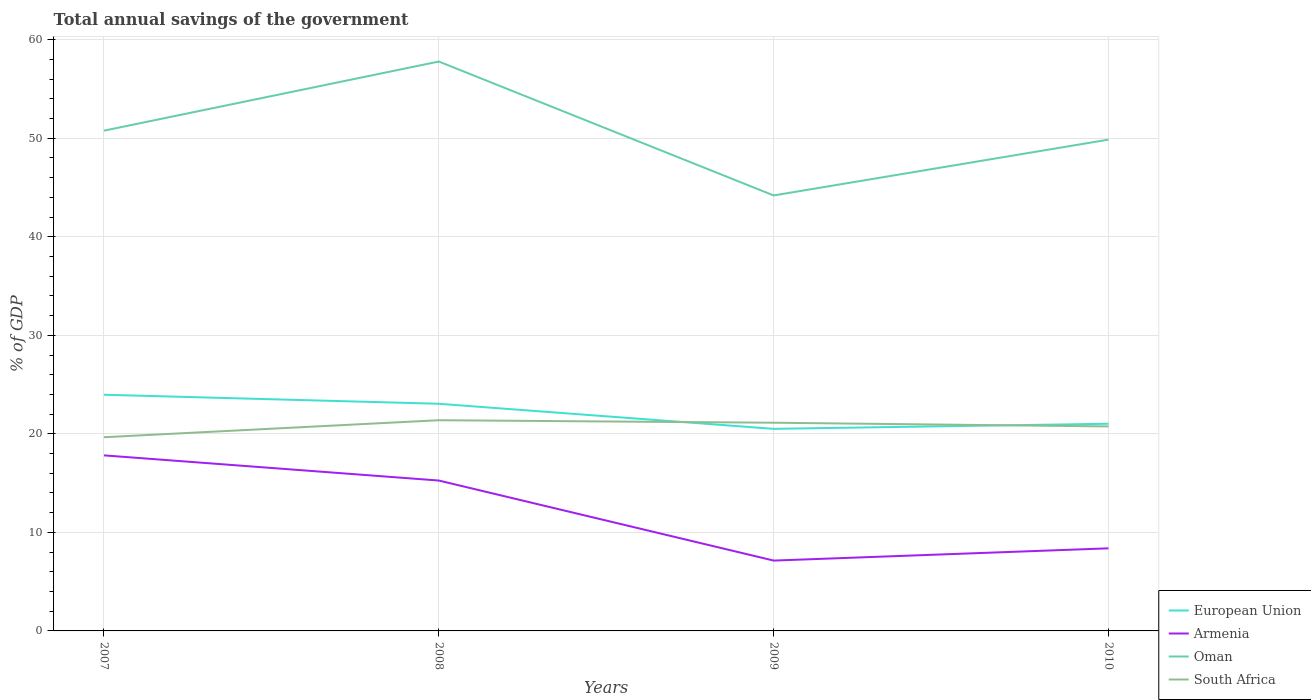Across all years, what is the maximum total annual savings of the government in Oman?
Provide a short and direct response. 44.2. What is the total total annual savings of the government in European Union in the graph?
Offer a terse response. -0.52. What is the difference between the highest and the second highest total annual savings of the government in Armenia?
Your answer should be compact. 10.68. How many lines are there?
Give a very brief answer. 4. How many years are there in the graph?
Provide a short and direct response. 4. Does the graph contain any zero values?
Your answer should be compact. No. Does the graph contain grids?
Provide a succinct answer. Yes. Where does the legend appear in the graph?
Ensure brevity in your answer.  Bottom right. How many legend labels are there?
Keep it short and to the point. 4. How are the legend labels stacked?
Your answer should be compact. Vertical. What is the title of the graph?
Provide a succinct answer. Total annual savings of the government. What is the label or title of the Y-axis?
Give a very brief answer. % of GDP. What is the % of GDP in European Union in 2007?
Keep it short and to the point. 23.97. What is the % of GDP in Armenia in 2007?
Ensure brevity in your answer.  17.82. What is the % of GDP of Oman in 2007?
Provide a succinct answer. 50.77. What is the % of GDP of South Africa in 2007?
Offer a terse response. 19.66. What is the % of GDP in European Union in 2008?
Provide a short and direct response. 23.05. What is the % of GDP of Armenia in 2008?
Your answer should be very brief. 15.26. What is the % of GDP of Oman in 2008?
Provide a short and direct response. 57.79. What is the % of GDP in South Africa in 2008?
Ensure brevity in your answer.  21.38. What is the % of GDP in European Union in 2009?
Make the answer very short. 20.51. What is the % of GDP of Armenia in 2009?
Ensure brevity in your answer.  7.14. What is the % of GDP of Oman in 2009?
Offer a very short reply. 44.2. What is the % of GDP in South Africa in 2009?
Your answer should be very brief. 21.13. What is the % of GDP of European Union in 2010?
Your answer should be compact. 21.03. What is the % of GDP in Armenia in 2010?
Make the answer very short. 8.38. What is the % of GDP in Oman in 2010?
Give a very brief answer. 49.86. What is the % of GDP of South Africa in 2010?
Ensure brevity in your answer.  20.75. Across all years, what is the maximum % of GDP in European Union?
Make the answer very short. 23.97. Across all years, what is the maximum % of GDP in Armenia?
Offer a terse response. 17.82. Across all years, what is the maximum % of GDP of Oman?
Offer a terse response. 57.79. Across all years, what is the maximum % of GDP in South Africa?
Give a very brief answer. 21.38. Across all years, what is the minimum % of GDP in European Union?
Offer a very short reply. 20.51. Across all years, what is the minimum % of GDP of Armenia?
Provide a short and direct response. 7.14. Across all years, what is the minimum % of GDP in Oman?
Your response must be concise. 44.2. Across all years, what is the minimum % of GDP in South Africa?
Your response must be concise. 19.66. What is the total % of GDP of European Union in the graph?
Provide a succinct answer. 88.56. What is the total % of GDP of Armenia in the graph?
Your response must be concise. 48.6. What is the total % of GDP in Oman in the graph?
Your answer should be compact. 202.62. What is the total % of GDP of South Africa in the graph?
Ensure brevity in your answer.  82.93. What is the difference between the % of GDP of European Union in 2007 and that in 2008?
Your answer should be compact. 0.92. What is the difference between the % of GDP in Armenia in 2007 and that in 2008?
Your answer should be very brief. 2.55. What is the difference between the % of GDP in Oman in 2007 and that in 2008?
Make the answer very short. -7.02. What is the difference between the % of GDP in South Africa in 2007 and that in 2008?
Offer a terse response. -1.73. What is the difference between the % of GDP of European Union in 2007 and that in 2009?
Offer a terse response. 3.46. What is the difference between the % of GDP in Armenia in 2007 and that in 2009?
Make the answer very short. 10.68. What is the difference between the % of GDP of Oman in 2007 and that in 2009?
Provide a succinct answer. 6.57. What is the difference between the % of GDP in South Africa in 2007 and that in 2009?
Your response must be concise. -1.47. What is the difference between the % of GDP of European Union in 2007 and that in 2010?
Your answer should be compact. 2.95. What is the difference between the % of GDP of Armenia in 2007 and that in 2010?
Offer a very short reply. 9.44. What is the difference between the % of GDP of Oman in 2007 and that in 2010?
Make the answer very short. 0.91. What is the difference between the % of GDP of South Africa in 2007 and that in 2010?
Keep it short and to the point. -1.1. What is the difference between the % of GDP of European Union in 2008 and that in 2009?
Give a very brief answer. 2.54. What is the difference between the % of GDP of Armenia in 2008 and that in 2009?
Ensure brevity in your answer.  8.12. What is the difference between the % of GDP of Oman in 2008 and that in 2009?
Provide a short and direct response. 13.59. What is the difference between the % of GDP of South Africa in 2008 and that in 2009?
Provide a succinct answer. 0.25. What is the difference between the % of GDP of European Union in 2008 and that in 2010?
Provide a short and direct response. 2.03. What is the difference between the % of GDP of Armenia in 2008 and that in 2010?
Make the answer very short. 6.88. What is the difference between the % of GDP of Oman in 2008 and that in 2010?
Keep it short and to the point. 7.92. What is the difference between the % of GDP of South Africa in 2008 and that in 2010?
Make the answer very short. 0.63. What is the difference between the % of GDP of European Union in 2009 and that in 2010?
Make the answer very short. -0.52. What is the difference between the % of GDP in Armenia in 2009 and that in 2010?
Ensure brevity in your answer.  -1.24. What is the difference between the % of GDP in Oman in 2009 and that in 2010?
Your answer should be very brief. -5.67. What is the difference between the % of GDP of South Africa in 2009 and that in 2010?
Make the answer very short. 0.38. What is the difference between the % of GDP of European Union in 2007 and the % of GDP of Armenia in 2008?
Your answer should be very brief. 8.71. What is the difference between the % of GDP of European Union in 2007 and the % of GDP of Oman in 2008?
Your response must be concise. -33.82. What is the difference between the % of GDP of European Union in 2007 and the % of GDP of South Africa in 2008?
Offer a terse response. 2.59. What is the difference between the % of GDP of Armenia in 2007 and the % of GDP of Oman in 2008?
Your answer should be compact. -39.97. What is the difference between the % of GDP of Armenia in 2007 and the % of GDP of South Africa in 2008?
Your response must be concise. -3.57. What is the difference between the % of GDP in Oman in 2007 and the % of GDP in South Africa in 2008?
Your answer should be compact. 29.39. What is the difference between the % of GDP in European Union in 2007 and the % of GDP in Armenia in 2009?
Offer a very short reply. 16.83. What is the difference between the % of GDP in European Union in 2007 and the % of GDP in Oman in 2009?
Your answer should be compact. -20.23. What is the difference between the % of GDP in European Union in 2007 and the % of GDP in South Africa in 2009?
Offer a terse response. 2.84. What is the difference between the % of GDP in Armenia in 2007 and the % of GDP in Oman in 2009?
Offer a very short reply. -26.38. What is the difference between the % of GDP in Armenia in 2007 and the % of GDP in South Africa in 2009?
Your answer should be compact. -3.31. What is the difference between the % of GDP in Oman in 2007 and the % of GDP in South Africa in 2009?
Provide a succinct answer. 29.64. What is the difference between the % of GDP of European Union in 2007 and the % of GDP of Armenia in 2010?
Offer a very short reply. 15.59. What is the difference between the % of GDP in European Union in 2007 and the % of GDP in Oman in 2010?
Offer a very short reply. -25.89. What is the difference between the % of GDP in European Union in 2007 and the % of GDP in South Africa in 2010?
Offer a very short reply. 3.22. What is the difference between the % of GDP in Armenia in 2007 and the % of GDP in Oman in 2010?
Your answer should be very brief. -32.05. What is the difference between the % of GDP of Armenia in 2007 and the % of GDP of South Africa in 2010?
Give a very brief answer. -2.94. What is the difference between the % of GDP in Oman in 2007 and the % of GDP in South Africa in 2010?
Offer a very short reply. 30.02. What is the difference between the % of GDP of European Union in 2008 and the % of GDP of Armenia in 2009?
Keep it short and to the point. 15.91. What is the difference between the % of GDP in European Union in 2008 and the % of GDP in Oman in 2009?
Keep it short and to the point. -21.14. What is the difference between the % of GDP in European Union in 2008 and the % of GDP in South Africa in 2009?
Give a very brief answer. 1.92. What is the difference between the % of GDP of Armenia in 2008 and the % of GDP of Oman in 2009?
Give a very brief answer. -28.94. What is the difference between the % of GDP in Armenia in 2008 and the % of GDP in South Africa in 2009?
Provide a short and direct response. -5.87. What is the difference between the % of GDP of Oman in 2008 and the % of GDP of South Africa in 2009?
Provide a short and direct response. 36.66. What is the difference between the % of GDP of European Union in 2008 and the % of GDP of Armenia in 2010?
Your answer should be very brief. 14.67. What is the difference between the % of GDP in European Union in 2008 and the % of GDP in Oman in 2010?
Keep it short and to the point. -26.81. What is the difference between the % of GDP of European Union in 2008 and the % of GDP of South Africa in 2010?
Provide a short and direct response. 2.3. What is the difference between the % of GDP of Armenia in 2008 and the % of GDP of Oman in 2010?
Your response must be concise. -34.6. What is the difference between the % of GDP in Armenia in 2008 and the % of GDP in South Africa in 2010?
Your response must be concise. -5.49. What is the difference between the % of GDP in Oman in 2008 and the % of GDP in South Africa in 2010?
Offer a terse response. 37.03. What is the difference between the % of GDP of European Union in 2009 and the % of GDP of Armenia in 2010?
Offer a terse response. 12.13. What is the difference between the % of GDP of European Union in 2009 and the % of GDP of Oman in 2010?
Offer a terse response. -29.35. What is the difference between the % of GDP in European Union in 2009 and the % of GDP in South Africa in 2010?
Make the answer very short. -0.24. What is the difference between the % of GDP of Armenia in 2009 and the % of GDP of Oman in 2010?
Your answer should be very brief. -42.72. What is the difference between the % of GDP of Armenia in 2009 and the % of GDP of South Africa in 2010?
Make the answer very short. -13.61. What is the difference between the % of GDP in Oman in 2009 and the % of GDP in South Africa in 2010?
Provide a succinct answer. 23.44. What is the average % of GDP in European Union per year?
Keep it short and to the point. 22.14. What is the average % of GDP in Armenia per year?
Offer a terse response. 12.15. What is the average % of GDP in Oman per year?
Provide a succinct answer. 50.66. What is the average % of GDP of South Africa per year?
Offer a terse response. 20.73. In the year 2007, what is the difference between the % of GDP in European Union and % of GDP in Armenia?
Offer a very short reply. 6.15. In the year 2007, what is the difference between the % of GDP in European Union and % of GDP in Oman?
Give a very brief answer. -26.8. In the year 2007, what is the difference between the % of GDP in European Union and % of GDP in South Africa?
Provide a short and direct response. 4.31. In the year 2007, what is the difference between the % of GDP of Armenia and % of GDP of Oman?
Keep it short and to the point. -32.95. In the year 2007, what is the difference between the % of GDP in Armenia and % of GDP in South Africa?
Keep it short and to the point. -1.84. In the year 2007, what is the difference between the % of GDP in Oman and % of GDP in South Africa?
Your answer should be compact. 31.11. In the year 2008, what is the difference between the % of GDP of European Union and % of GDP of Armenia?
Your answer should be compact. 7.79. In the year 2008, what is the difference between the % of GDP of European Union and % of GDP of Oman?
Keep it short and to the point. -34.73. In the year 2008, what is the difference between the % of GDP of European Union and % of GDP of South Africa?
Make the answer very short. 1.67. In the year 2008, what is the difference between the % of GDP in Armenia and % of GDP in Oman?
Provide a short and direct response. -42.53. In the year 2008, what is the difference between the % of GDP in Armenia and % of GDP in South Africa?
Give a very brief answer. -6.12. In the year 2008, what is the difference between the % of GDP of Oman and % of GDP of South Africa?
Offer a very short reply. 36.4. In the year 2009, what is the difference between the % of GDP of European Union and % of GDP of Armenia?
Your answer should be compact. 13.37. In the year 2009, what is the difference between the % of GDP of European Union and % of GDP of Oman?
Your answer should be very brief. -23.69. In the year 2009, what is the difference between the % of GDP in European Union and % of GDP in South Africa?
Make the answer very short. -0.62. In the year 2009, what is the difference between the % of GDP in Armenia and % of GDP in Oman?
Keep it short and to the point. -37.06. In the year 2009, what is the difference between the % of GDP in Armenia and % of GDP in South Africa?
Keep it short and to the point. -13.99. In the year 2009, what is the difference between the % of GDP of Oman and % of GDP of South Africa?
Keep it short and to the point. 23.07. In the year 2010, what is the difference between the % of GDP in European Union and % of GDP in Armenia?
Provide a succinct answer. 12.64. In the year 2010, what is the difference between the % of GDP of European Union and % of GDP of Oman?
Give a very brief answer. -28.84. In the year 2010, what is the difference between the % of GDP in European Union and % of GDP in South Africa?
Make the answer very short. 0.27. In the year 2010, what is the difference between the % of GDP in Armenia and % of GDP in Oman?
Provide a short and direct response. -41.48. In the year 2010, what is the difference between the % of GDP in Armenia and % of GDP in South Africa?
Keep it short and to the point. -12.37. In the year 2010, what is the difference between the % of GDP in Oman and % of GDP in South Africa?
Provide a short and direct response. 29.11. What is the ratio of the % of GDP of European Union in 2007 to that in 2008?
Provide a succinct answer. 1.04. What is the ratio of the % of GDP in Armenia in 2007 to that in 2008?
Provide a succinct answer. 1.17. What is the ratio of the % of GDP of Oman in 2007 to that in 2008?
Offer a terse response. 0.88. What is the ratio of the % of GDP in South Africa in 2007 to that in 2008?
Your answer should be compact. 0.92. What is the ratio of the % of GDP of European Union in 2007 to that in 2009?
Make the answer very short. 1.17. What is the ratio of the % of GDP in Armenia in 2007 to that in 2009?
Keep it short and to the point. 2.5. What is the ratio of the % of GDP in Oman in 2007 to that in 2009?
Ensure brevity in your answer.  1.15. What is the ratio of the % of GDP of South Africa in 2007 to that in 2009?
Ensure brevity in your answer.  0.93. What is the ratio of the % of GDP in European Union in 2007 to that in 2010?
Give a very brief answer. 1.14. What is the ratio of the % of GDP of Armenia in 2007 to that in 2010?
Give a very brief answer. 2.13. What is the ratio of the % of GDP in Oman in 2007 to that in 2010?
Give a very brief answer. 1.02. What is the ratio of the % of GDP of South Africa in 2007 to that in 2010?
Keep it short and to the point. 0.95. What is the ratio of the % of GDP in European Union in 2008 to that in 2009?
Offer a very short reply. 1.12. What is the ratio of the % of GDP of Armenia in 2008 to that in 2009?
Keep it short and to the point. 2.14. What is the ratio of the % of GDP of Oman in 2008 to that in 2009?
Make the answer very short. 1.31. What is the ratio of the % of GDP of European Union in 2008 to that in 2010?
Your answer should be very brief. 1.1. What is the ratio of the % of GDP of Armenia in 2008 to that in 2010?
Your answer should be very brief. 1.82. What is the ratio of the % of GDP in Oman in 2008 to that in 2010?
Keep it short and to the point. 1.16. What is the ratio of the % of GDP of South Africa in 2008 to that in 2010?
Offer a terse response. 1.03. What is the ratio of the % of GDP in European Union in 2009 to that in 2010?
Your response must be concise. 0.98. What is the ratio of the % of GDP in Armenia in 2009 to that in 2010?
Your answer should be compact. 0.85. What is the ratio of the % of GDP of Oman in 2009 to that in 2010?
Offer a terse response. 0.89. What is the ratio of the % of GDP of South Africa in 2009 to that in 2010?
Keep it short and to the point. 1.02. What is the difference between the highest and the second highest % of GDP in European Union?
Provide a succinct answer. 0.92. What is the difference between the highest and the second highest % of GDP in Armenia?
Your answer should be compact. 2.55. What is the difference between the highest and the second highest % of GDP of Oman?
Provide a short and direct response. 7.02. What is the difference between the highest and the second highest % of GDP of South Africa?
Your answer should be compact. 0.25. What is the difference between the highest and the lowest % of GDP of European Union?
Your response must be concise. 3.46. What is the difference between the highest and the lowest % of GDP of Armenia?
Your answer should be compact. 10.68. What is the difference between the highest and the lowest % of GDP of Oman?
Keep it short and to the point. 13.59. What is the difference between the highest and the lowest % of GDP of South Africa?
Offer a terse response. 1.73. 